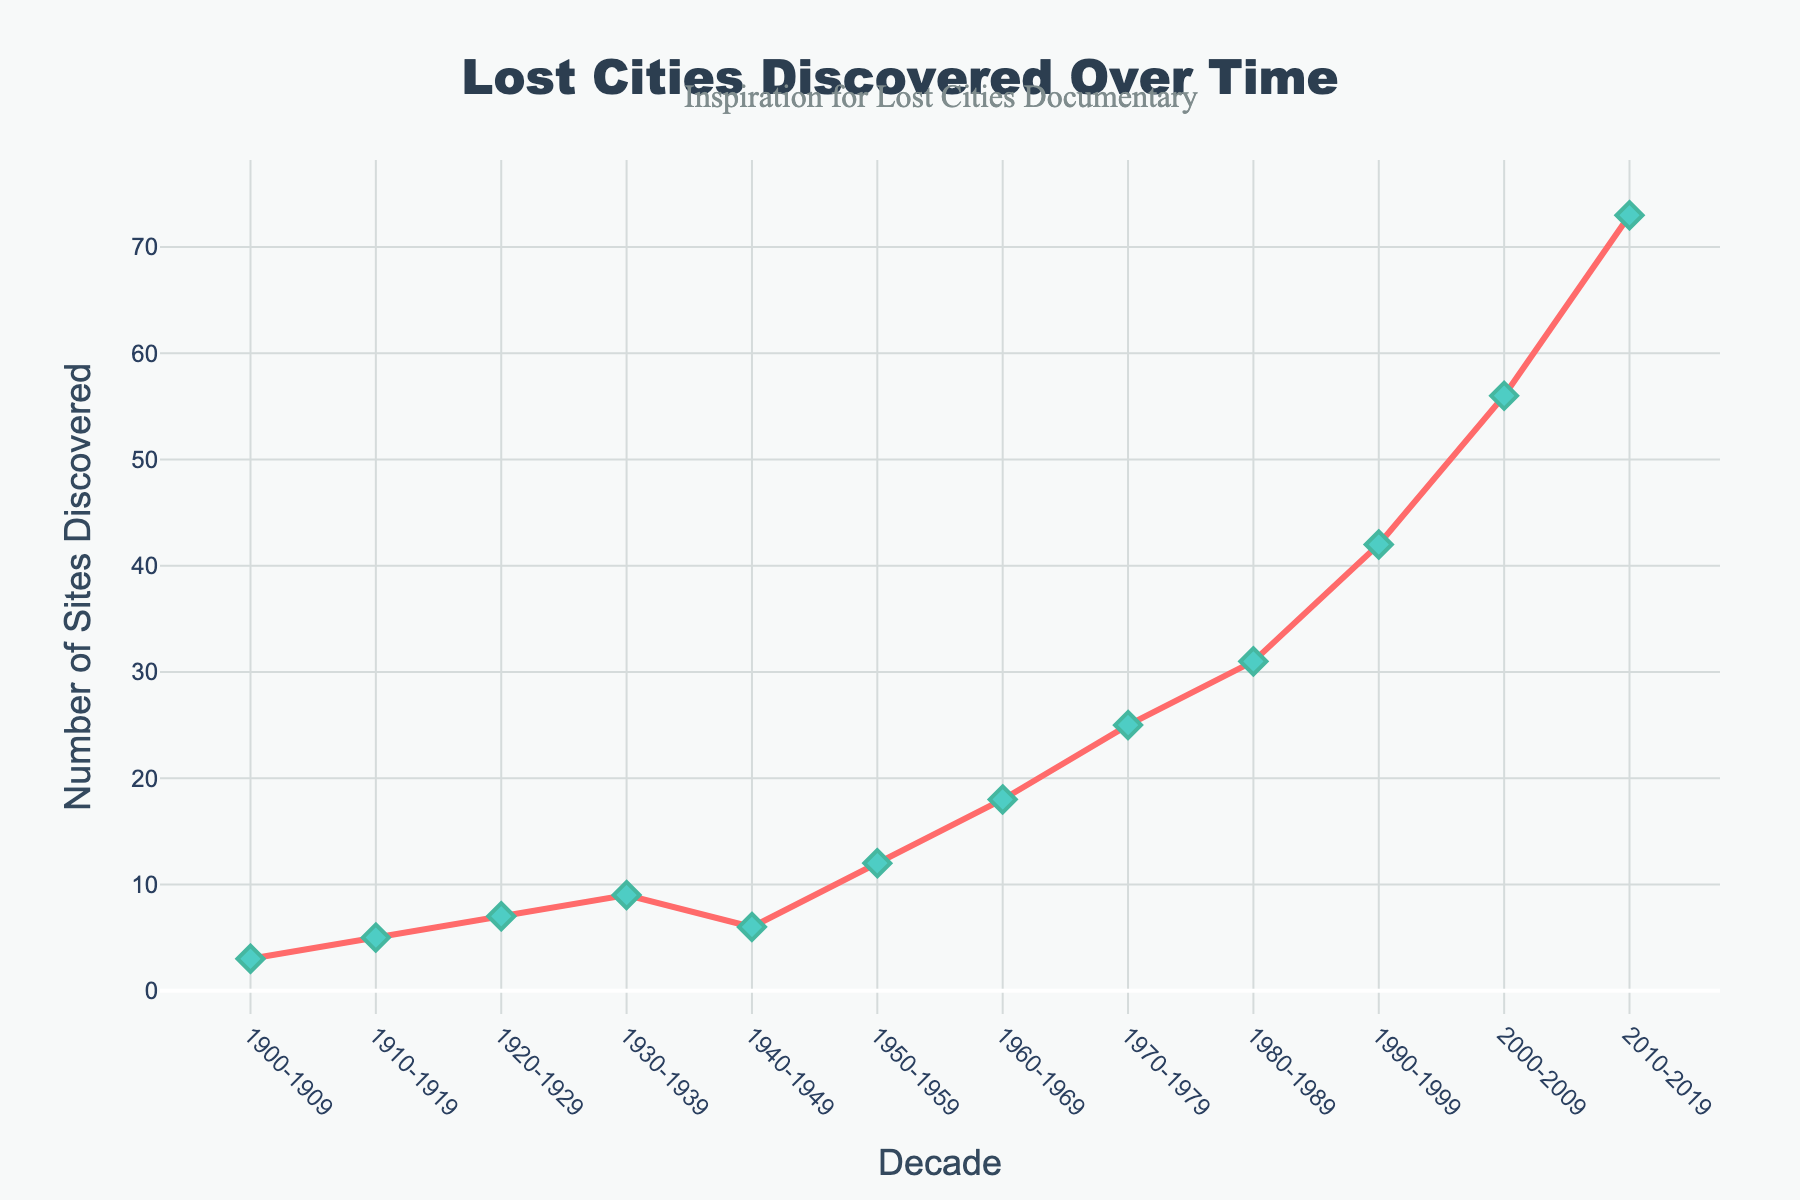What's the highest number of sites discovered in a single decade? The line representing the sites discovered per decade peaks at the rightmost point on the x-axis, indicating the highest number of sites discovered. This corresponds to the decade 2010-2019, with 73 sites discovered.
Answer: 73 How many sites were discovered in the 1950s compared to the 1920s? To answer this, look at the figures for the 1950-1959 and 1920-1929 decades. For 1950-1959, there are 12 sites, and for 1920-1929, there are 7 sites. Subtracting these, 12 - 7, shows an increase of 5 sites.
Answer: 5 more sites Which decade experienced a decrease in the number of sites discovered compared to its preceding decade? By examining each decade's data, we can see the number of sites discovered from 1930-1939 (9 sites) compared to the 1940-1949 (6 sites) shows a decrease.
Answer: 1940-1949 What's the total number of sites discovered between 1990 and 2009? To find the total, add the sites discovered in the 1990s and 2000s. For 1990-1999 there are 42 sites, and for 2000-2009 there are 56 sites. So, 42 + 56 = 98.
Answer: 98 Compare the slope of the line from 1960-1969 to 1970-1979 with the slope from 1990-1999 to 2000-2009. Which is steeper? The number of sites from 1960-1969 increases from 18 to 25, a change of 7. From 1990-1999 to 2000-2009, the number increases from 42 to 56, a change of 14. Because the latter increase (14 sites) is double the former (7 sites), the slope from 1990-1999 to 2000-2009 is steeper.
Answer: 1990-1999 to 2000-2009 What's the average number of sites discovered per decade from 1900 to 1959? Calculate the average by summing the sites for 1900-1909 (3), 1910-1919 (5), 1920-1929 (7), 1930-1939 (9), 1940-1949 (6), and 1950-1959 (12). The total is 3 + 5 + 7 + 9 + 6 + 12 = 42. Divide by the 6 decades: 42/6.
Answer: 7 Which decade saw the largest single-decade rise in site discoveries? To determine this, calculate the difference in sites discovered from one decade to the next. The largest difference occurs between 2000-2009 (56 sites) and 2010-2019 (73 sites), with a rise of 73 - 56 = 17.
Answer: 2010-2019 